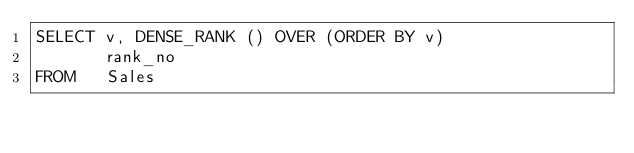<code> <loc_0><loc_0><loc_500><loc_500><_SQL_>SELECT v, DENSE_RANK () OVER (ORDER BY v)
       rank_no
FROM   Sales</code> 